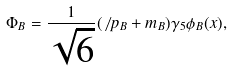<formula> <loc_0><loc_0><loc_500><loc_500>\Phi _ { B } = \frac { 1 } { \sqrt { 6 } } ( \not \, p _ { B } + m _ { B } ) \gamma _ { 5 } \phi _ { B } ( { x } ) ,</formula> 